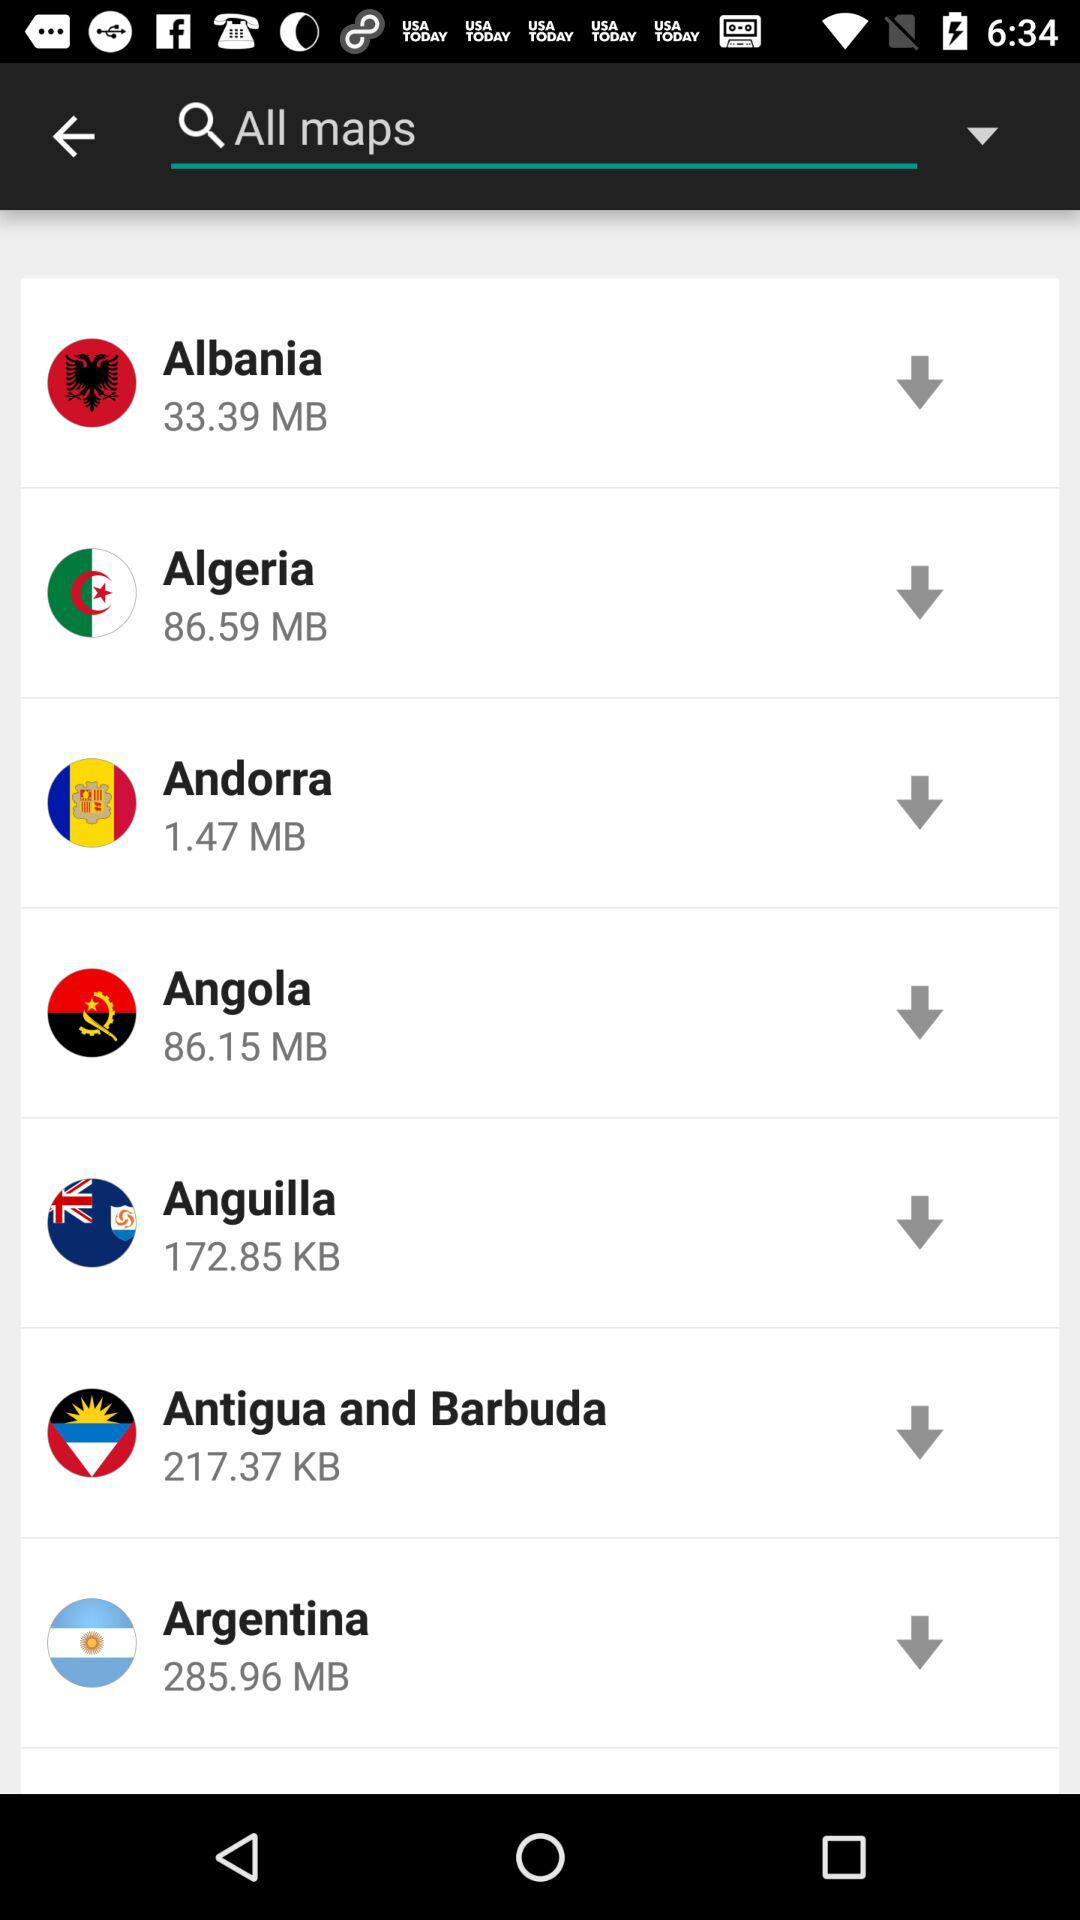What is the size of the "Algeria" file? The size of the "Algeria" file is 86.59 MB. 